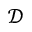<formula> <loc_0><loc_0><loc_500><loc_500>\mathcal { D }</formula> 